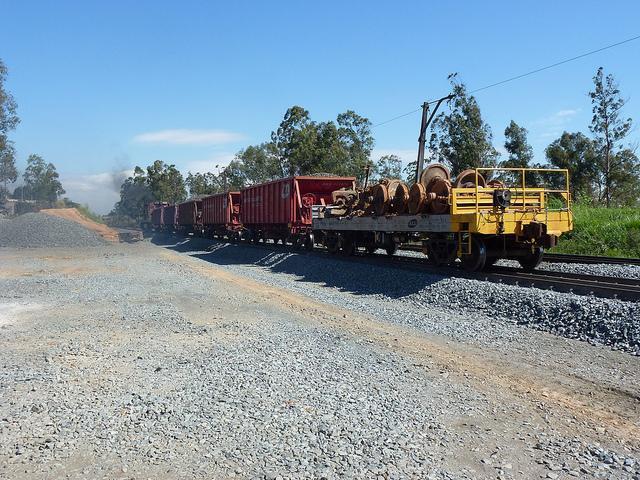How many trains are there?
Give a very brief answer. 1. 